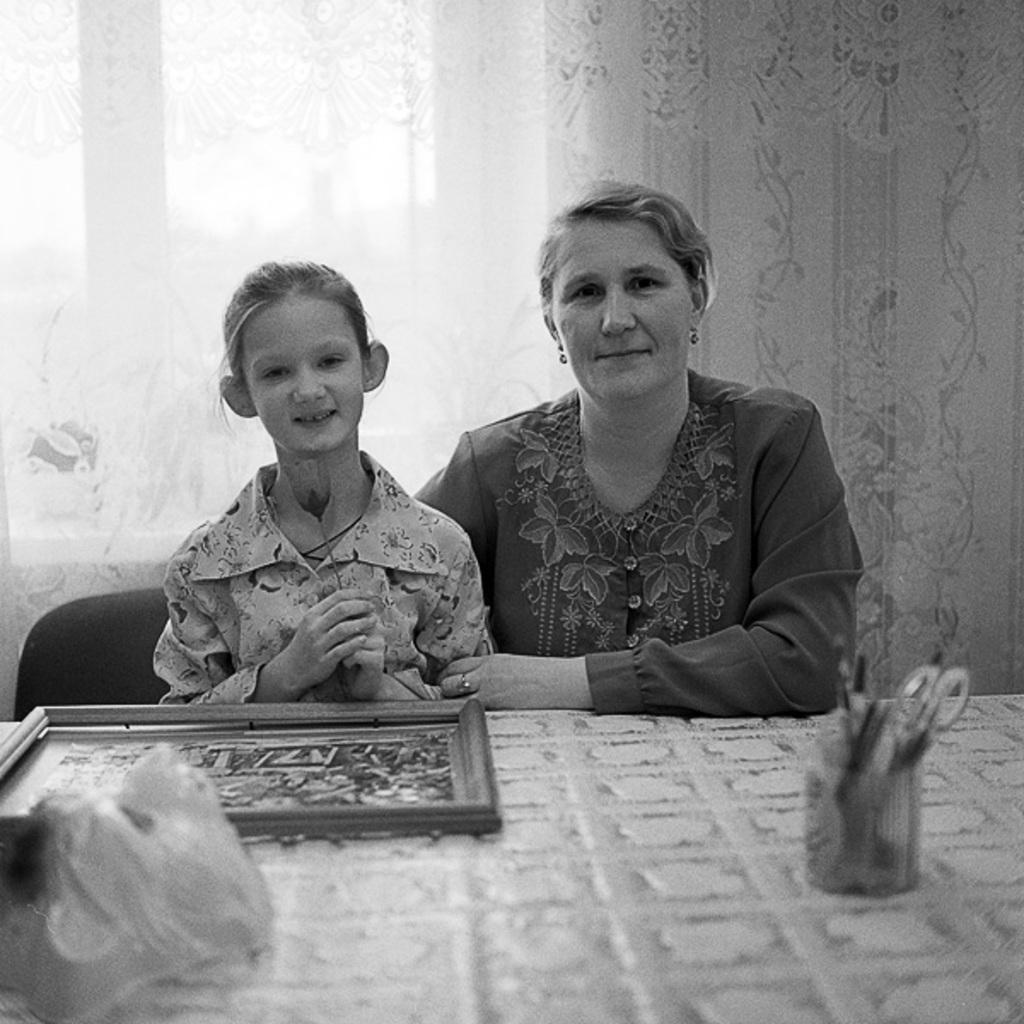How many people are in the image? There are two ladies in the image. What are the ladies doing in the image? The ladies are sitting on chairs. What is present in front of the ladies? There is a table in front of the ladies. What objects can be seen on the table? There is a pen stand and a frame on the table. What is visible in the background of the image? There is a curtain in the background of the image. Can you hear the ladies laughing in the image? There is no sound in the image, so we cannot hear the ladies laughing. 